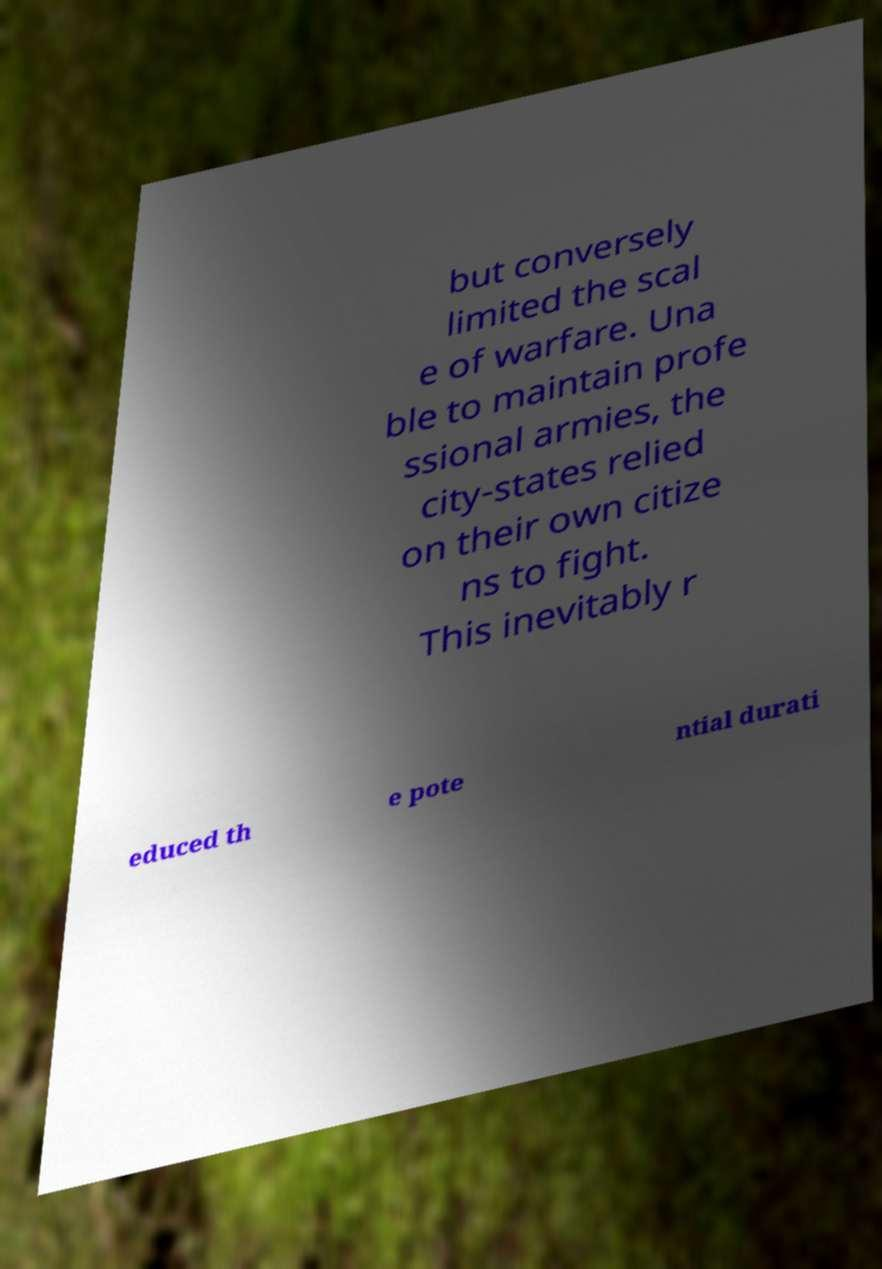Please identify and transcribe the text found in this image. but conversely limited the scal e of warfare. Una ble to maintain profe ssional armies, the city-states relied on their own citize ns to fight. This inevitably r educed th e pote ntial durati 